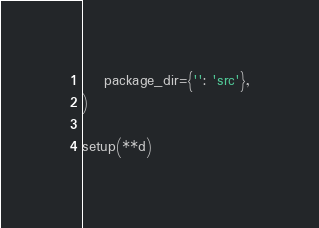<code> <loc_0><loc_0><loc_500><loc_500><_Python_>    package_dir={'': 'src'},
)

setup(**d)
</code> 